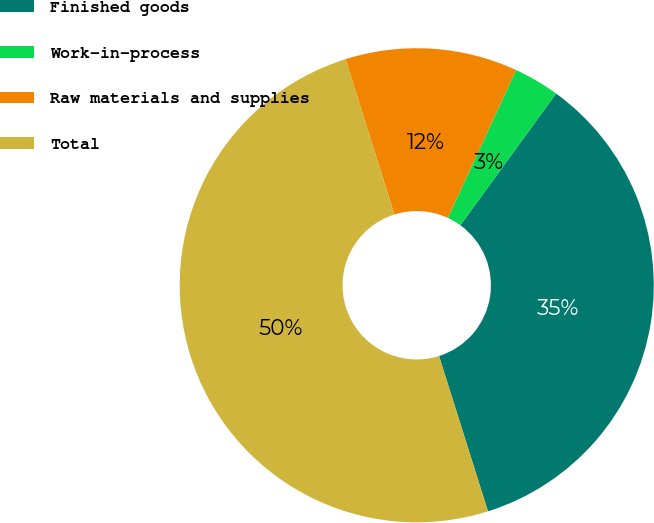Convert chart to OTSL. <chart><loc_0><loc_0><loc_500><loc_500><pie_chart><fcel>Finished goods<fcel>Work-in-process<fcel>Raw materials and supplies<fcel>Total<nl><fcel>35.14%<fcel>3.12%<fcel>11.74%<fcel>50.0%<nl></chart> 